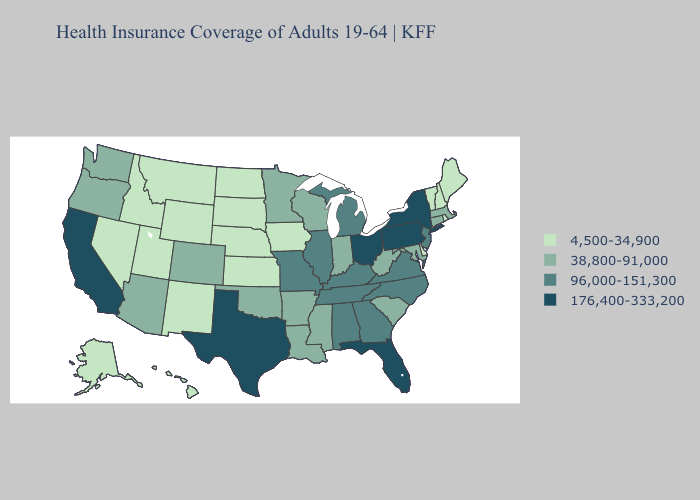Which states have the lowest value in the MidWest?
Write a very short answer. Iowa, Kansas, Nebraska, North Dakota, South Dakota. Does Washington have the lowest value in the USA?
Concise answer only. No. Among the states that border Missouri , does Oklahoma have the highest value?
Give a very brief answer. No. What is the value of Utah?
Concise answer only. 4,500-34,900. Name the states that have a value in the range 4,500-34,900?
Concise answer only. Alaska, Delaware, Hawaii, Idaho, Iowa, Kansas, Maine, Montana, Nebraska, Nevada, New Hampshire, New Mexico, North Dakota, Rhode Island, South Dakota, Utah, Vermont, Wyoming. What is the lowest value in the USA?
Be succinct. 4,500-34,900. Which states hav the highest value in the MidWest?
Short answer required. Ohio. Does Delaware have the lowest value in the South?
Concise answer only. Yes. Name the states that have a value in the range 176,400-333,200?
Answer briefly. California, Florida, New York, Ohio, Pennsylvania, Texas. Name the states that have a value in the range 38,800-91,000?
Keep it brief. Arizona, Arkansas, Colorado, Connecticut, Indiana, Louisiana, Maryland, Massachusetts, Minnesota, Mississippi, Oklahoma, Oregon, South Carolina, Washington, West Virginia, Wisconsin. What is the lowest value in the USA?
Give a very brief answer. 4,500-34,900. Name the states that have a value in the range 176,400-333,200?
Give a very brief answer. California, Florida, New York, Ohio, Pennsylvania, Texas. Among the states that border Illinois , does Wisconsin have the highest value?
Be succinct. No. Among the states that border Pennsylvania , does New Jersey have the highest value?
Write a very short answer. No. Name the states that have a value in the range 176,400-333,200?
Quick response, please. California, Florida, New York, Ohio, Pennsylvania, Texas. 